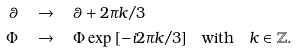<formula> <loc_0><loc_0><loc_500><loc_500>\theta & \quad \rightarrow \quad \theta + 2 \pi k / 3 \\ \Phi & \quad \rightarrow \quad \Phi \exp { [ - i 2 \pi k / 3 ] } \quad \text {with} \quad k \in \mathbb { Z } \text  .</formula> 